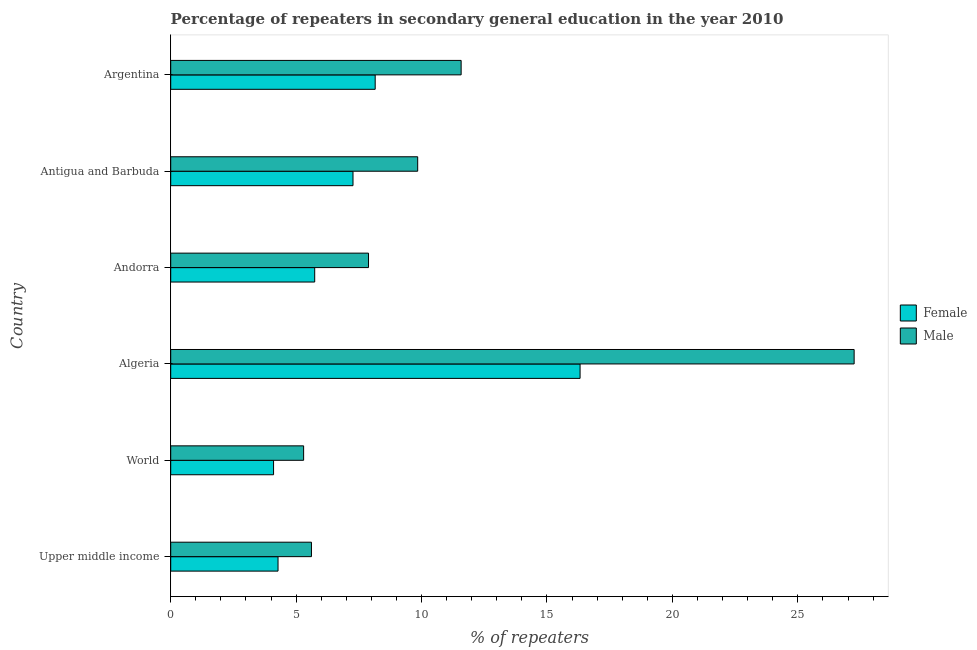How many bars are there on the 1st tick from the top?
Offer a terse response. 2. What is the label of the 3rd group of bars from the top?
Provide a succinct answer. Andorra. In how many cases, is the number of bars for a given country not equal to the number of legend labels?
Your answer should be very brief. 0. What is the percentage of female repeaters in Upper middle income?
Keep it short and to the point. 4.28. Across all countries, what is the maximum percentage of male repeaters?
Provide a short and direct response. 27.24. Across all countries, what is the minimum percentage of male repeaters?
Keep it short and to the point. 5.3. In which country was the percentage of male repeaters maximum?
Provide a succinct answer. Algeria. In which country was the percentage of male repeaters minimum?
Offer a very short reply. World. What is the total percentage of male repeaters in the graph?
Ensure brevity in your answer.  67.46. What is the difference between the percentage of female repeaters in Andorra and that in World?
Provide a short and direct response. 1.64. What is the difference between the percentage of female repeaters in World and the percentage of male repeaters in Algeria?
Your response must be concise. -23.14. What is the average percentage of female repeaters per country?
Make the answer very short. 7.64. What is the difference between the percentage of male repeaters and percentage of female repeaters in World?
Your response must be concise. 1.2. What is the ratio of the percentage of female repeaters in Algeria to that in Argentina?
Ensure brevity in your answer.  2. What is the difference between the highest and the second highest percentage of male repeaters?
Your answer should be compact. 15.67. What is the difference between the highest and the lowest percentage of male repeaters?
Your answer should be very brief. 21.95. In how many countries, is the percentage of male repeaters greater than the average percentage of male repeaters taken over all countries?
Give a very brief answer. 2. What does the 1st bar from the bottom in Algeria represents?
Offer a terse response. Female. Are all the bars in the graph horizontal?
Your answer should be very brief. Yes. How many countries are there in the graph?
Provide a short and direct response. 6. How are the legend labels stacked?
Offer a terse response. Vertical. What is the title of the graph?
Offer a very short reply. Percentage of repeaters in secondary general education in the year 2010. Does "Canada" appear as one of the legend labels in the graph?
Keep it short and to the point. No. What is the label or title of the X-axis?
Your answer should be compact. % of repeaters. What is the label or title of the Y-axis?
Keep it short and to the point. Country. What is the % of repeaters of Female in Upper middle income?
Provide a succinct answer. 4.28. What is the % of repeaters in Male in Upper middle income?
Keep it short and to the point. 5.61. What is the % of repeaters of Female in World?
Give a very brief answer. 4.1. What is the % of repeaters of Male in World?
Provide a short and direct response. 5.3. What is the % of repeaters in Female in Algeria?
Keep it short and to the point. 16.32. What is the % of repeaters in Male in Algeria?
Provide a succinct answer. 27.24. What is the % of repeaters in Female in Andorra?
Ensure brevity in your answer.  5.74. What is the % of repeaters in Male in Andorra?
Offer a very short reply. 7.89. What is the % of repeaters of Female in Antigua and Barbuda?
Your answer should be compact. 7.27. What is the % of repeaters of Male in Antigua and Barbuda?
Your response must be concise. 9.85. What is the % of repeaters of Female in Argentina?
Provide a short and direct response. 8.15. What is the % of repeaters in Male in Argentina?
Provide a succinct answer. 11.58. Across all countries, what is the maximum % of repeaters in Female?
Provide a short and direct response. 16.32. Across all countries, what is the maximum % of repeaters of Male?
Your response must be concise. 27.24. Across all countries, what is the minimum % of repeaters of Female?
Your answer should be compact. 4.1. Across all countries, what is the minimum % of repeaters of Male?
Make the answer very short. 5.3. What is the total % of repeaters of Female in the graph?
Make the answer very short. 45.86. What is the total % of repeaters of Male in the graph?
Offer a terse response. 67.46. What is the difference between the % of repeaters in Female in Upper middle income and that in World?
Provide a short and direct response. 0.18. What is the difference between the % of repeaters of Male in Upper middle income and that in World?
Your response must be concise. 0.31. What is the difference between the % of repeaters of Female in Upper middle income and that in Algeria?
Make the answer very short. -12.04. What is the difference between the % of repeaters of Male in Upper middle income and that in Algeria?
Provide a short and direct response. -21.63. What is the difference between the % of repeaters of Female in Upper middle income and that in Andorra?
Make the answer very short. -1.46. What is the difference between the % of repeaters of Male in Upper middle income and that in Andorra?
Make the answer very short. -2.27. What is the difference between the % of repeaters of Female in Upper middle income and that in Antigua and Barbuda?
Offer a terse response. -2.99. What is the difference between the % of repeaters in Male in Upper middle income and that in Antigua and Barbuda?
Provide a succinct answer. -4.24. What is the difference between the % of repeaters in Female in Upper middle income and that in Argentina?
Ensure brevity in your answer.  -3.87. What is the difference between the % of repeaters of Male in Upper middle income and that in Argentina?
Ensure brevity in your answer.  -5.97. What is the difference between the % of repeaters of Female in World and that in Algeria?
Give a very brief answer. -12.22. What is the difference between the % of repeaters of Male in World and that in Algeria?
Offer a terse response. -21.95. What is the difference between the % of repeaters in Female in World and that in Andorra?
Offer a terse response. -1.64. What is the difference between the % of repeaters in Male in World and that in Andorra?
Your response must be concise. -2.59. What is the difference between the % of repeaters in Female in World and that in Antigua and Barbuda?
Your answer should be very brief. -3.17. What is the difference between the % of repeaters of Male in World and that in Antigua and Barbuda?
Offer a very short reply. -4.55. What is the difference between the % of repeaters of Female in World and that in Argentina?
Your response must be concise. -4.05. What is the difference between the % of repeaters of Male in World and that in Argentina?
Offer a terse response. -6.28. What is the difference between the % of repeaters of Female in Algeria and that in Andorra?
Offer a terse response. 10.58. What is the difference between the % of repeaters in Male in Algeria and that in Andorra?
Provide a short and direct response. 19.36. What is the difference between the % of repeaters in Female in Algeria and that in Antigua and Barbuda?
Offer a terse response. 9.05. What is the difference between the % of repeaters in Male in Algeria and that in Antigua and Barbuda?
Your response must be concise. 17.4. What is the difference between the % of repeaters in Female in Algeria and that in Argentina?
Provide a short and direct response. 8.17. What is the difference between the % of repeaters in Male in Algeria and that in Argentina?
Make the answer very short. 15.67. What is the difference between the % of repeaters of Female in Andorra and that in Antigua and Barbuda?
Keep it short and to the point. -1.53. What is the difference between the % of repeaters of Male in Andorra and that in Antigua and Barbuda?
Provide a short and direct response. -1.96. What is the difference between the % of repeaters in Female in Andorra and that in Argentina?
Make the answer very short. -2.41. What is the difference between the % of repeaters in Male in Andorra and that in Argentina?
Your answer should be compact. -3.69. What is the difference between the % of repeaters of Female in Antigua and Barbuda and that in Argentina?
Offer a terse response. -0.88. What is the difference between the % of repeaters in Male in Antigua and Barbuda and that in Argentina?
Offer a very short reply. -1.73. What is the difference between the % of repeaters in Female in Upper middle income and the % of repeaters in Male in World?
Your answer should be compact. -1.02. What is the difference between the % of repeaters of Female in Upper middle income and the % of repeaters of Male in Algeria?
Offer a terse response. -22.97. What is the difference between the % of repeaters of Female in Upper middle income and the % of repeaters of Male in Andorra?
Make the answer very short. -3.61. What is the difference between the % of repeaters in Female in Upper middle income and the % of repeaters in Male in Antigua and Barbuda?
Ensure brevity in your answer.  -5.57. What is the difference between the % of repeaters in Female in Upper middle income and the % of repeaters in Male in Argentina?
Give a very brief answer. -7.3. What is the difference between the % of repeaters of Female in World and the % of repeaters of Male in Algeria?
Your answer should be very brief. -23.14. What is the difference between the % of repeaters of Female in World and the % of repeaters of Male in Andorra?
Offer a very short reply. -3.79. What is the difference between the % of repeaters in Female in World and the % of repeaters in Male in Antigua and Barbuda?
Give a very brief answer. -5.75. What is the difference between the % of repeaters of Female in World and the % of repeaters of Male in Argentina?
Offer a very short reply. -7.48. What is the difference between the % of repeaters of Female in Algeria and the % of repeaters of Male in Andorra?
Give a very brief answer. 8.43. What is the difference between the % of repeaters in Female in Algeria and the % of repeaters in Male in Antigua and Barbuda?
Provide a succinct answer. 6.47. What is the difference between the % of repeaters in Female in Algeria and the % of repeaters in Male in Argentina?
Ensure brevity in your answer.  4.74. What is the difference between the % of repeaters of Female in Andorra and the % of repeaters of Male in Antigua and Barbuda?
Ensure brevity in your answer.  -4.11. What is the difference between the % of repeaters of Female in Andorra and the % of repeaters of Male in Argentina?
Offer a very short reply. -5.84. What is the difference between the % of repeaters in Female in Antigua and Barbuda and the % of repeaters in Male in Argentina?
Provide a succinct answer. -4.31. What is the average % of repeaters in Female per country?
Give a very brief answer. 7.64. What is the average % of repeaters of Male per country?
Your answer should be very brief. 11.24. What is the difference between the % of repeaters in Female and % of repeaters in Male in Upper middle income?
Your answer should be very brief. -1.33. What is the difference between the % of repeaters of Female and % of repeaters of Male in World?
Offer a very short reply. -1.2. What is the difference between the % of repeaters in Female and % of repeaters in Male in Algeria?
Offer a terse response. -10.93. What is the difference between the % of repeaters in Female and % of repeaters in Male in Andorra?
Ensure brevity in your answer.  -2.15. What is the difference between the % of repeaters in Female and % of repeaters in Male in Antigua and Barbuda?
Provide a short and direct response. -2.58. What is the difference between the % of repeaters of Female and % of repeaters of Male in Argentina?
Make the answer very short. -3.43. What is the ratio of the % of repeaters of Female in Upper middle income to that in World?
Give a very brief answer. 1.04. What is the ratio of the % of repeaters in Male in Upper middle income to that in World?
Provide a short and direct response. 1.06. What is the ratio of the % of repeaters of Female in Upper middle income to that in Algeria?
Provide a short and direct response. 0.26. What is the ratio of the % of repeaters in Male in Upper middle income to that in Algeria?
Keep it short and to the point. 0.21. What is the ratio of the % of repeaters of Female in Upper middle income to that in Andorra?
Make the answer very short. 0.75. What is the ratio of the % of repeaters of Male in Upper middle income to that in Andorra?
Provide a short and direct response. 0.71. What is the ratio of the % of repeaters in Female in Upper middle income to that in Antigua and Barbuda?
Provide a succinct answer. 0.59. What is the ratio of the % of repeaters of Male in Upper middle income to that in Antigua and Barbuda?
Your response must be concise. 0.57. What is the ratio of the % of repeaters of Female in Upper middle income to that in Argentina?
Make the answer very short. 0.52. What is the ratio of the % of repeaters in Male in Upper middle income to that in Argentina?
Your response must be concise. 0.48. What is the ratio of the % of repeaters of Female in World to that in Algeria?
Keep it short and to the point. 0.25. What is the ratio of the % of repeaters in Male in World to that in Algeria?
Your answer should be compact. 0.19. What is the ratio of the % of repeaters in Female in World to that in Andorra?
Offer a terse response. 0.71. What is the ratio of the % of repeaters of Male in World to that in Andorra?
Make the answer very short. 0.67. What is the ratio of the % of repeaters of Female in World to that in Antigua and Barbuda?
Your answer should be compact. 0.56. What is the ratio of the % of repeaters in Male in World to that in Antigua and Barbuda?
Your answer should be compact. 0.54. What is the ratio of the % of repeaters of Female in World to that in Argentina?
Provide a short and direct response. 0.5. What is the ratio of the % of repeaters of Male in World to that in Argentina?
Give a very brief answer. 0.46. What is the ratio of the % of repeaters of Female in Algeria to that in Andorra?
Provide a succinct answer. 2.84. What is the ratio of the % of repeaters in Male in Algeria to that in Andorra?
Provide a succinct answer. 3.46. What is the ratio of the % of repeaters in Female in Algeria to that in Antigua and Barbuda?
Provide a short and direct response. 2.25. What is the ratio of the % of repeaters of Male in Algeria to that in Antigua and Barbuda?
Offer a very short reply. 2.77. What is the ratio of the % of repeaters of Female in Algeria to that in Argentina?
Keep it short and to the point. 2. What is the ratio of the % of repeaters of Male in Algeria to that in Argentina?
Provide a short and direct response. 2.35. What is the ratio of the % of repeaters of Female in Andorra to that in Antigua and Barbuda?
Provide a short and direct response. 0.79. What is the ratio of the % of repeaters of Male in Andorra to that in Antigua and Barbuda?
Your answer should be very brief. 0.8. What is the ratio of the % of repeaters in Female in Andorra to that in Argentina?
Your answer should be compact. 0.7. What is the ratio of the % of repeaters in Male in Andorra to that in Argentina?
Your answer should be compact. 0.68. What is the ratio of the % of repeaters of Female in Antigua and Barbuda to that in Argentina?
Offer a very short reply. 0.89. What is the ratio of the % of repeaters in Male in Antigua and Barbuda to that in Argentina?
Give a very brief answer. 0.85. What is the difference between the highest and the second highest % of repeaters of Female?
Provide a short and direct response. 8.17. What is the difference between the highest and the second highest % of repeaters in Male?
Your answer should be compact. 15.67. What is the difference between the highest and the lowest % of repeaters of Female?
Keep it short and to the point. 12.22. What is the difference between the highest and the lowest % of repeaters of Male?
Offer a terse response. 21.95. 